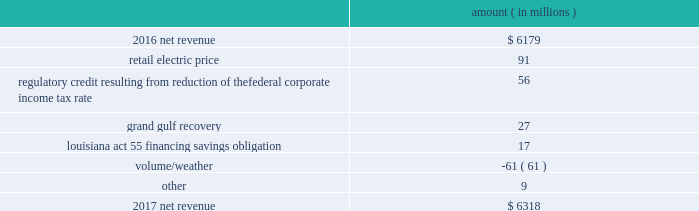Results of operations for 2016 include : 1 ) $ 2836 million ( $ 1829 million net-of-tax ) of impairment and related charges primarily to write down the carrying values of the entergy wholesale commodities 2019 palisades , indian point 2 , and indian point 3 plants and related assets to their fair values ; 2 ) a reduction of income tax expense , net of unrecognized tax benefits , of $ 238 million as a result of a change in the tax classification of a legal entity that owned one of the entergy wholesale commodities nuclear power plants ; income tax benefits as a result of the settlement of the 2010-2011 irs audit , including a $ 75 million tax benefit recognized by entergy louisiana related to the treatment of the vidalia purchased power agreement and a $ 54 million net benefit recognized by entergy louisiana related to the treatment of proceeds received in 2010 for the financing of hurricane gustav and hurricane ike storm costs pursuant to louisiana act 55 ; and 3 ) a reduction in expenses of $ 100 million ( $ 64 million net-of-tax ) due to the effects of recording in 2016 the final court decisions in several lawsuits against the doe related to spent nuclear fuel storage costs .
See note 14 to the financial statements for further discussion of the impairment and related charges , see note 3 to the financial statements for additional discussion of the income tax items , and see note 8 to the financial statements for discussion of the spent nuclear fuel litigation .
Net revenue utility following is an analysis of the change in net revenue comparing 2017 to 2016 .
Amount ( in millions ) .
The retail electric price variance is primarily due to : 2022 the implementation of formula rate plan rates effective with the first billing cycle of january 2017 at entergy arkansas and an increase in base rates effective february 24 , 2016 , each as approved by the apsc .
A significant portion of the base rate increase was related to the purchase of power block 2 of the union power station in march 2016 ; 2022 a provision recorded in 2016 related to the settlement of the waterford 3 replacement steam generator prudence review proceeding ; 2022 the implementation of the transmission cost recovery factor rider at entergy texas , effective september 2016 , and an increase in the transmission cost recovery factor rider rate , effective march 2017 , as approved by the puct ; and 2022 an increase in rates at entergy mississippi , as approved by the mpsc , effective with the first billing cycle of july 2016 .
See note 2 to the financial statements for further discussion of the rate proceedings and the waterford 3 replacement steam generator prudence review proceeding .
See note 14 to the financial statements for discussion of the union power station purchase .
Entergy corporation and subsidiaries management 2019s financial discussion and analysis .
What is the percent change in net revenue from 2016 to 2017? 
Computations: ((6318 - 6179) / 6179)
Answer: 0.0225. 